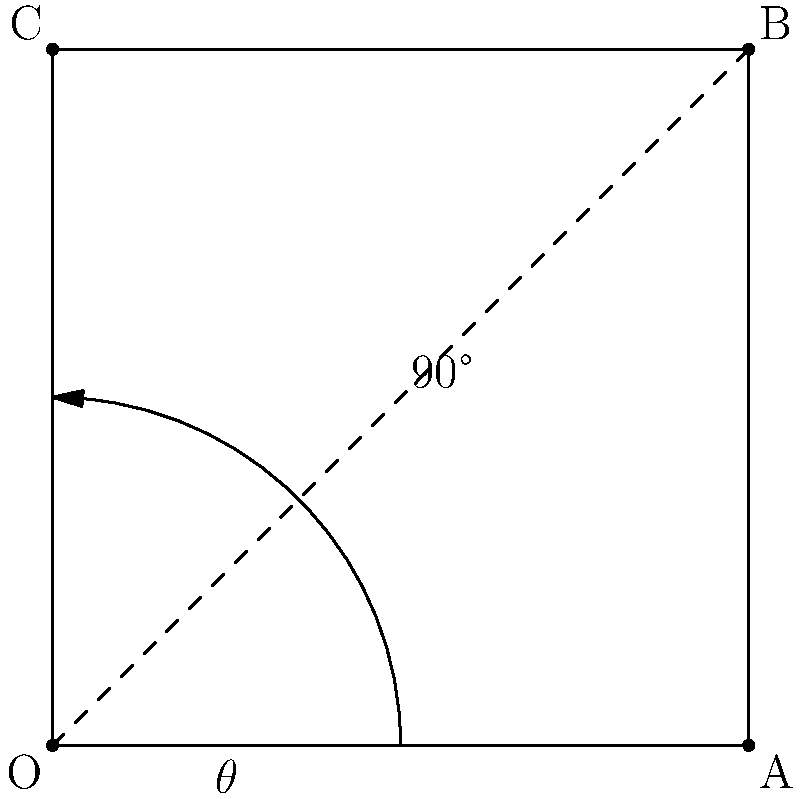In a community center project for at-risk youth, you're designing an interactive geometry display. A square OABC is rotated 90° counterclockwise around point O. If the initial angle between OA and OB is $\theta$, what is the angle between OA and OB after the rotation? Let's approach this step-by-step:

1) Initially, OA and OB form an angle $\theta$. This is one of the angles of the square.

2) In a square, all angles are 90°. Therefore, $\theta = 90°$.

3) When we rotate the square 90° counterclockwise around O:
   - Point A will move to where C was
   - Point B will move to where A was
   - Point C will move to where B was

4) After rotation, the new angle between OA and OB will be:
   - The original angle ($\theta$ or 90°)
   + The rotation angle (90°)

5) Therefore, the new angle = $90° + 90° = 180°$

This result shows that after rotation, OA and OB will form a straight line.
Answer: 180° 